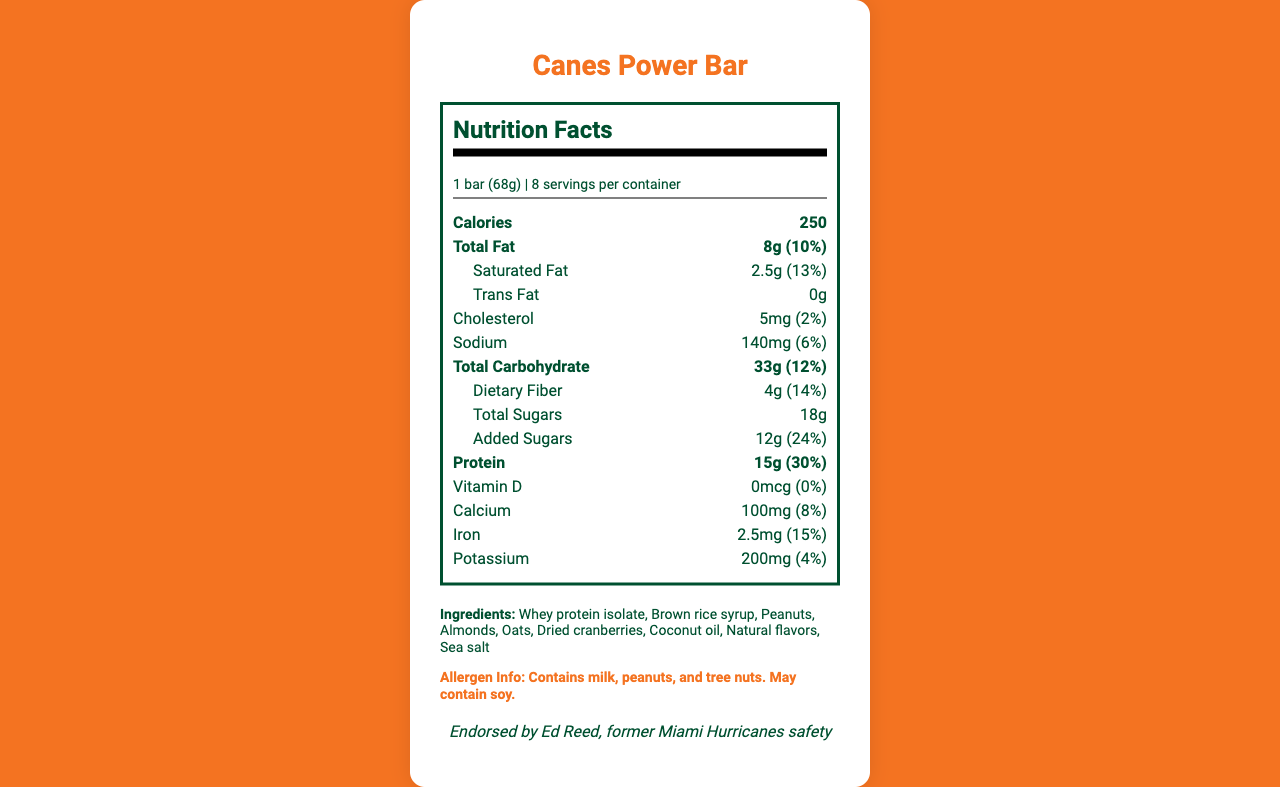what is the serving size of the Canes Power Bar? The serving size is mentioned at the beginning of the nutrition label under the heading "Nutrition Facts."
Answer: 1 bar (68g) how many servings are in each container of Canes Power Bar? The document states "8 servings per container" in the serving information section.
Answer: 8 what is the total fat content in one serving? The total fat content is specified as 8g, which is 10% of the daily value per serving.
Answer: 8g (10%) how much protein does each serving provide? The protein content is listed as 15g per serving, which is 30% of the daily value.
Answer: 15g (30%) what is the nostalgic flavor of the Canes Power Bar? This nostalgic flavor is mentioned in the data provided about the product.
Answer: Inspired by the famous Cuban sandwiches from Miami's Little Havana which former Miami Hurricanes player endorses the Canes Power Bar? A. Ed Reed B. Michael Irvin C. Ray Lewis The document states that the bar is endorsed by Ed Reed, a former Miami Hurricanes safety.
Answer: A. Ed Reed which of the following is not an ingredient of the Canes Power Bar? A. Whey protein isolate B. Brown rice syrup C. Soy protein isolate D. Dried cranberries The ingredient list does not include soy protein isolate; it mentions whey protein isolate, brown rice syrup, and dried cranberries.
Answer: C. Soy protein isolate what is the daily value percentage of added sugars in one serving? The daily value percentage for added sugars is indicated as 24%.
Answer: 24% true or false: the Canes Power Bar contains sea salt. Sea salt is listed among the ingredients in the document.
Answer: True summarize the main nutritional facts of the Canes Power Bar. The summary encompasses the most critical details: serving size, calories, macronutrients, ingredients, and allergen information.
Answer: The Canes Power Bar is a post-workout recovery bar endorsed by Ed Reed and inspired by Miami's Cuban sandwiches. Each bar weighs 68g, with 8 servings per container. Each serving provides 250 calories, 8g of total fat, 15g of protein, 33g of carbohydrates, and includes ingredients like whey protein isolate and dried cranberries. It contains allergens like milk, peanuts, and tree nuts. what are the recovery benefits provided by the Canes Power Bar? The recovery benefits are explicitly mentioned in the details provided about the product.
Answer: 20% of daily protein needs, Rich in complex carbohydrates for sustained energy, Contains electrolytes for proper hydration how much cholesterol is in each serving and what is its daily value percentage? The document lists the cholesterol content as 5mg per serving, which is 2% of the daily value.
Answer: 5mg (2%) how many grams of dietary fiber are in one serving? The dietary fiber content is listed as 4g per serving, which is 14% of the daily value.
Answer: 4g (14%) does the Canes Power Bar contain any vitamin D? The document states that the bar contains 0mcg of vitamin D, which is 0% of the daily value.
Answer: No what is the color of the packaging for the Canes Power Bar? The document mentions that the packaging is orange and green.
Answer: Orange and green how much potassium is in one serving of the Canes Power Bar? The potassium content is listed as 200mg per serving, which is 4% of the daily value.
Answer: 200mg (4%) can the exact manufacturing location of the Canes Power Bar be determined from the document? The document does not provide information about the manufacturing location.
Answer: Cannot be determined 